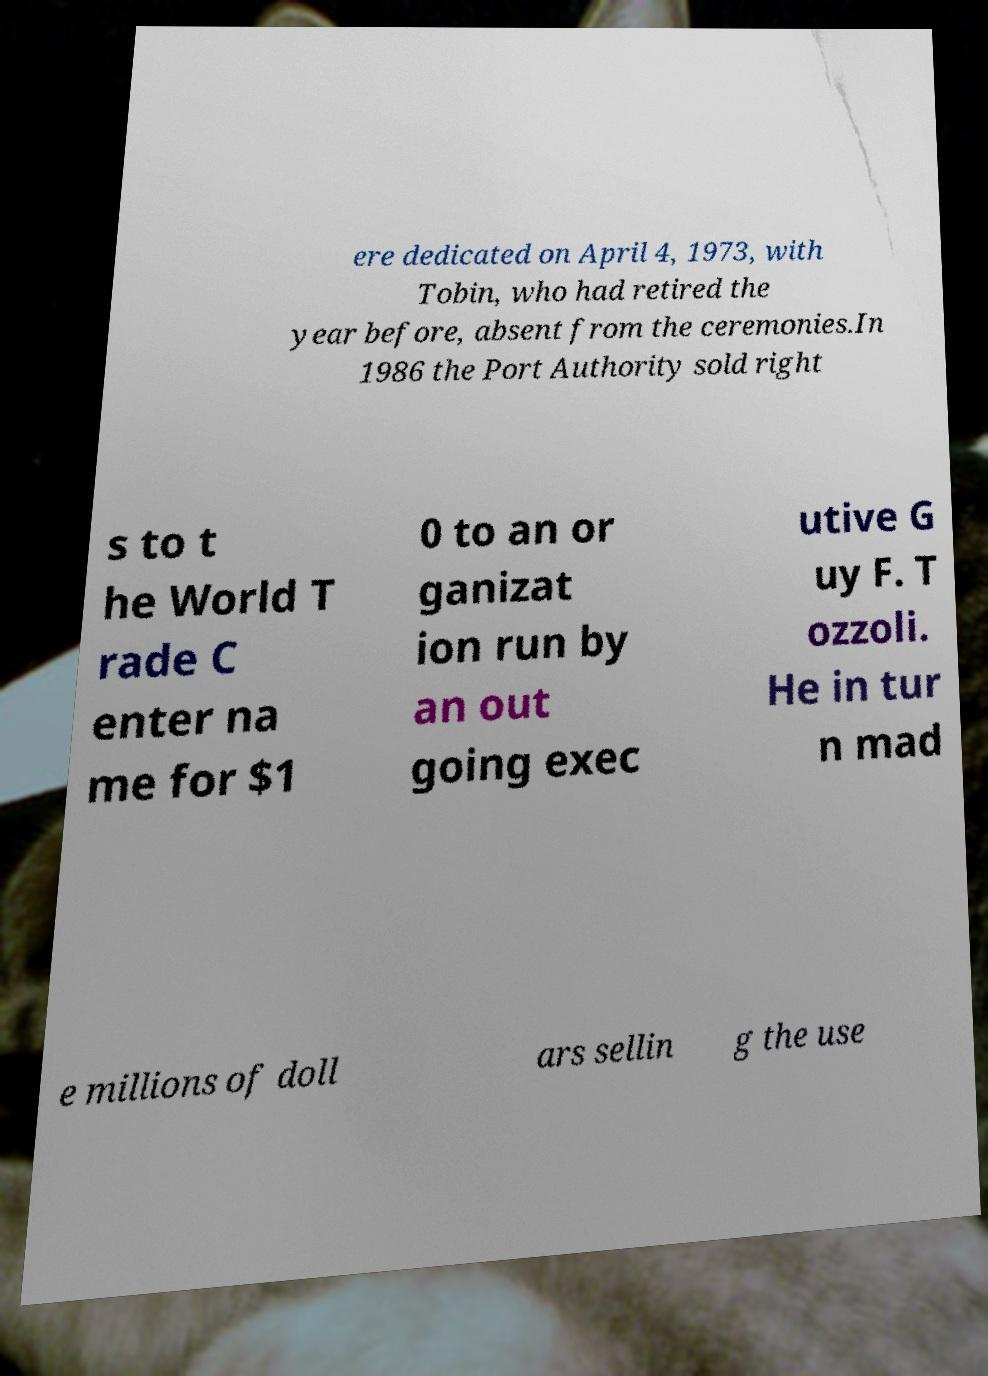What messages or text are displayed in this image? I need them in a readable, typed format. ere dedicated on April 4, 1973, with Tobin, who had retired the year before, absent from the ceremonies.In 1986 the Port Authority sold right s to t he World T rade C enter na me for $1 0 to an or ganizat ion run by an out going exec utive G uy F. T ozzoli. He in tur n mad e millions of doll ars sellin g the use 